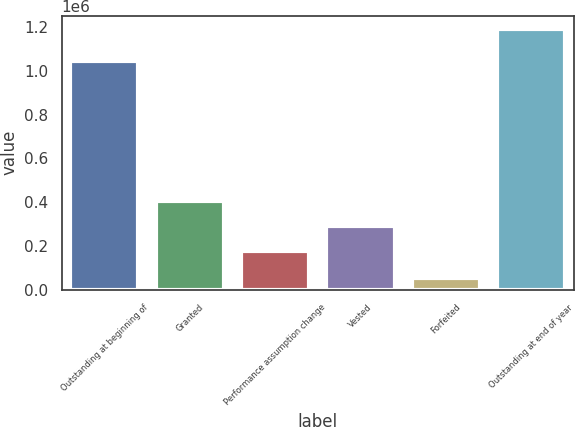Convert chart. <chart><loc_0><loc_0><loc_500><loc_500><bar_chart><fcel>Outstanding at beginning of<fcel>Granted<fcel>Performance assumption change<fcel>Vested<fcel>Forfeited<fcel>Outstanding at end of year<nl><fcel>1.0465e+06<fcel>404801<fcel>176725<fcel>290763<fcel>50985<fcel>1.19137e+06<nl></chart> 